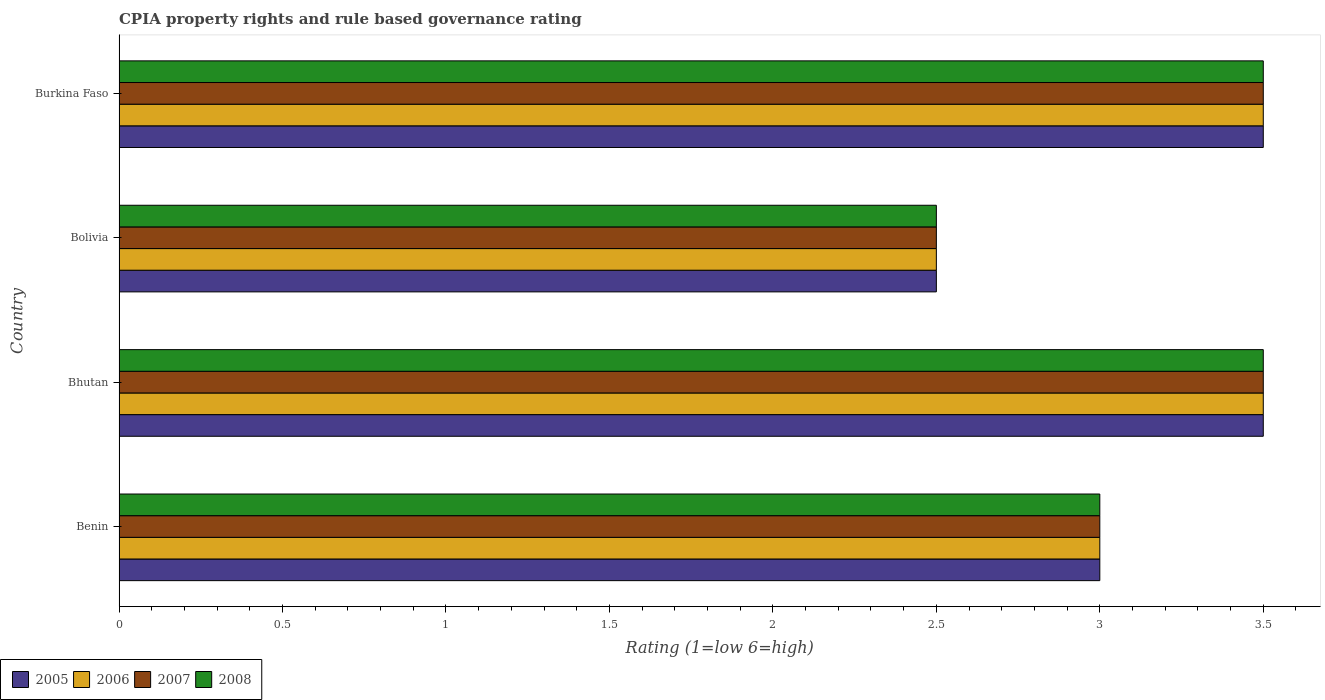Are the number of bars per tick equal to the number of legend labels?
Make the answer very short. Yes. What is the label of the 4th group of bars from the top?
Provide a short and direct response. Benin. In how many cases, is the number of bars for a given country not equal to the number of legend labels?
Provide a succinct answer. 0. What is the CPIA rating in 2005 in Bolivia?
Your response must be concise. 2.5. Across all countries, what is the minimum CPIA rating in 2006?
Your answer should be very brief. 2.5. In which country was the CPIA rating in 2007 maximum?
Your response must be concise. Bhutan. What is the total CPIA rating in 2008 in the graph?
Make the answer very short. 12.5. What is the difference between the CPIA rating in 2007 in Benin and that in Bolivia?
Ensure brevity in your answer.  0.5. What is the average CPIA rating in 2005 per country?
Offer a terse response. 3.12. What is the difference between the CPIA rating in 2008 and CPIA rating in 2005 in Bolivia?
Provide a succinct answer. 0. What is the ratio of the CPIA rating in 2005 in Bhutan to that in Burkina Faso?
Your answer should be compact. 1. What is the difference between the highest and the second highest CPIA rating in 2005?
Provide a succinct answer. 0. In how many countries, is the CPIA rating in 2007 greater than the average CPIA rating in 2007 taken over all countries?
Your answer should be compact. 2. Is the sum of the CPIA rating in 2007 in Bhutan and Burkina Faso greater than the maximum CPIA rating in 2008 across all countries?
Offer a terse response. Yes. Is it the case that in every country, the sum of the CPIA rating in 2005 and CPIA rating in 2007 is greater than the sum of CPIA rating in 2008 and CPIA rating in 2006?
Ensure brevity in your answer.  No. What does the 1st bar from the top in Burkina Faso represents?
Provide a short and direct response. 2008. What does the 1st bar from the bottom in Bolivia represents?
Offer a very short reply. 2005. How many bars are there?
Your response must be concise. 16. Are all the bars in the graph horizontal?
Your response must be concise. Yes. How many countries are there in the graph?
Provide a short and direct response. 4. Are the values on the major ticks of X-axis written in scientific E-notation?
Give a very brief answer. No. Does the graph contain any zero values?
Provide a succinct answer. No. Does the graph contain grids?
Give a very brief answer. No. Where does the legend appear in the graph?
Ensure brevity in your answer.  Bottom left. How many legend labels are there?
Offer a terse response. 4. How are the legend labels stacked?
Your answer should be very brief. Horizontal. What is the title of the graph?
Provide a short and direct response. CPIA property rights and rule based governance rating. Does "1977" appear as one of the legend labels in the graph?
Offer a very short reply. No. What is the Rating (1=low 6=high) in 2007 in Bhutan?
Your answer should be compact. 3.5. What is the Rating (1=low 6=high) of 2005 in Bolivia?
Make the answer very short. 2.5. What is the Rating (1=low 6=high) of 2008 in Bolivia?
Give a very brief answer. 2.5. What is the Rating (1=low 6=high) in 2006 in Burkina Faso?
Make the answer very short. 3.5. What is the Rating (1=low 6=high) in 2008 in Burkina Faso?
Make the answer very short. 3.5. Across all countries, what is the maximum Rating (1=low 6=high) of 2007?
Your answer should be very brief. 3.5. Across all countries, what is the minimum Rating (1=low 6=high) of 2005?
Provide a short and direct response. 2.5. What is the total Rating (1=low 6=high) of 2006 in the graph?
Offer a terse response. 12.5. What is the total Rating (1=low 6=high) of 2007 in the graph?
Your response must be concise. 12.5. What is the total Rating (1=low 6=high) in 2008 in the graph?
Your answer should be compact. 12.5. What is the difference between the Rating (1=low 6=high) of 2006 in Benin and that in Bhutan?
Your answer should be very brief. -0.5. What is the difference between the Rating (1=low 6=high) of 2007 in Benin and that in Bhutan?
Ensure brevity in your answer.  -0.5. What is the difference between the Rating (1=low 6=high) of 2006 in Benin and that in Bolivia?
Offer a terse response. 0.5. What is the difference between the Rating (1=low 6=high) of 2007 in Benin and that in Bolivia?
Give a very brief answer. 0.5. What is the difference between the Rating (1=low 6=high) in 2005 in Benin and that in Burkina Faso?
Give a very brief answer. -0.5. What is the difference between the Rating (1=low 6=high) in 2007 in Benin and that in Burkina Faso?
Ensure brevity in your answer.  -0.5. What is the difference between the Rating (1=low 6=high) in 2008 in Benin and that in Burkina Faso?
Your response must be concise. -0.5. What is the difference between the Rating (1=low 6=high) of 2006 in Bhutan and that in Bolivia?
Provide a short and direct response. 1. What is the difference between the Rating (1=low 6=high) of 2007 in Bhutan and that in Burkina Faso?
Offer a terse response. 0. What is the difference between the Rating (1=low 6=high) in 2005 in Bolivia and that in Burkina Faso?
Keep it short and to the point. -1. What is the difference between the Rating (1=low 6=high) of 2006 in Bolivia and that in Burkina Faso?
Offer a very short reply. -1. What is the difference between the Rating (1=low 6=high) in 2007 in Bolivia and that in Burkina Faso?
Your answer should be compact. -1. What is the difference between the Rating (1=low 6=high) in 2005 in Benin and the Rating (1=low 6=high) in 2008 in Bhutan?
Offer a terse response. -0.5. What is the difference between the Rating (1=low 6=high) in 2006 in Benin and the Rating (1=low 6=high) in 2008 in Bhutan?
Offer a very short reply. -0.5. What is the difference between the Rating (1=low 6=high) of 2005 in Benin and the Rating (1=low 6=high) of 2008 in Bolivia?
Your answer should be very brief. 0.5. What is the difference between the Rating (1=low 6=high) of 2006 in Benin and the Rating (1=low 6=high) of 2007 in Bolivia?
Your response must be concise. 0.5. What is the difference between the Rating (1=low 6=high) of 2007 in Benin and the Rating (1=low 6=high) of 2008 in Bolivia?
Provide a short and direct response. 0.5. What is the difference between the Rating (1=low 6=high) of 2005 in Benin and the Rating (1=low 6=high) of 2007 in Burkina Faso?
Keep it short and to the point. -0.5. What is the difference between the Rating (1=low 6=high) of 2005 in Benin and the Rating (1=low 6=high) of 2008 in Burkina Faso?
Your response must be concise. -0.5. What is the difference between the Rating (1=low 6=high) of 2006 in Benin and the Rating (1=low 6=high) of 2008 in Burkina Faso?
Provide a succinct answer. -0.5. What is the difference between the Rating (1=low 6=high) in 2007 in Benin and the Rating (1=low 6=high) in 2008 in Burkina Faso?
Offer a very short reply. -0.5. What is the difference between the Rating (1=low 6=high) of 2005 in Bhutan and the Rating (1=low 6=high) of 2006 in Bolivia?
Offer a terse response. 1. What is the difference between the Rating (1=low 6=high) in 2005 in Bhutan and the Rating (1=low 6=high) in 2007 in Bolivia?
Provide a succinct answer. 1. What is the difference between the Rating (1=low 6=high) of 2005 in Bhutan and the Rating (1=low 6=high) of 2008 in Bolivia?
Offer a terse response. 1. What is the difference between the Rating (1=low 6=high) of 2006 in Bhutan and the Rating (1=low 6=high) of 2007 in Bolivia?
Provide a short and direct response. 1. What is the difference between the Rating (1=low 6=high) of 2005 in Bhutan and the Rating (1=low 6=high) of 2008 in Burkina Faso?
Keep it short and to the point. 0. What is the difference between the Rating (1=low 6=high) in 2006 in Bolivia and the Rating (1=low 6=high) in 2008 in Burkina Faso?
Your answer should be compact. -1. What is the average Rating (1=low 6=high) of 2005 per country?
Give a very brief answer. 3.12. What is the average Rating (1=low 6=high) in 2006 per country?
Your answer should be compact. 3.12. What is the average Rating (1=low 6=high) in 2007 per country?
Ensure brevity in your answer.  3.12. What is the average Rating (1=low 6=high) in 2008 per country?
Keep it short and to the point. 3.12. What is the difference between the Rating (1=low 6=high) of 2005 and Rating (1=low 6=high) of 2006 in Benin?
Ensure brevity in your answer.  0. What is the difference between the Rating (1=low 6=high) in 2006 and Rating (1=low 6=high) in 2007 in Benin?
Offer a terse response. 0. What is the difference between the Rating (1=low 6=high) of 2006 and Rating (1=low 6=high) of 2008 in Benin?
Your answer should be compact. 0. What is the difference between the Rating (1=low 6=high) in 2005 and Rating (1=low 6=high) in 2007 in Bhutan?
Your answer should be very brief. 0. What is the difference between the Rating (1=low 6=high) of 2006 and Rating (1=low 6=high) of 2008 in Bhutan?
Offer a terse response. 0. What is the difference between the Rating (1=low 6=high) in 2007 and Rating (1=low 6=high) in 2008 in Bhutan?
Keep it short and to the point. 0. What is the difference between the Rating (1=low 6=high) in 2005 and Rating (1=low 6=high) in 2006 in Bolivia?
Offer a very short reply. 0. What is the difference between the Rating (1=low 6=high) in 2007 and Rating (1=low 6=high) in 2008 in Bolivia?
Give a very brief answer. 0. What is the difference between the Rating (1=low 6=high) in 2005 and Rating (1=low 6=high) in 2008 in Burkina Faso?
Make the answer very short. 0. What is the difference between the Rating (1=low 6=high) in 2006 and Rating (1=low 6=high) in 2008 in Burkina Faso?
Ensure brevity in your answer.  0. What is the ratio of the Rating (1=low 6=high) of 2007 in Benin to that in Bhutan?
Your answer should be compact. 0.86. What is the ratio of the Rating (1=low 6=high) of 2008 in Benin to that in Bhutan?
Provide a short and direct response. 0.86. What is the ratio of the Rating (1=low 6=high) in 2005 in Benin to that in Bolivia?
Keep it short and to the point. 1.2. What is the ratio of the Rating (1=low 6=high) in 2006 in Benin to that in Burkina Faso?
Give a very brief answer. 0.86. What is the ratio of the Rating (1=low 6=high) in 2007 in Benin to that in Burkina Faso?
Your answer should be very brief. 0.86. What is the ratio of the Rating (1=low 6=high) of 2007 in Bhutan to that in Burkina Faso?
Ensure brevity in your answer.  1. What is the ratio of the Rating (1=low 6=high) in 2008 in Bhutan to that in Burkina Faso?
Make the answer very short. 1. What is the ratio of the Rating (1=low 6=high) in 2007 in Bolivia to that in Burkina Faso?
Provide a short and direct response. 0.71. What is the difference between the highest and the second highest Rating (1=low 6=high) in 2005?
Give a very brief answer. 0. What is the difference between the highest and the second highest Rating (1=low 6=high) in 2006?
Offer a terse response. 0. What is the difference between the highest and the second highest Rating (1=low 6=high) in 2007?
Provide a short and direct response. 0. What is the difference between the highest and the lowest Rating (1=low 6=high) in 2005?
Your answer should be compact. 1. What is the difference between the highest and the lowest Rating (1=low 6=high) of 2006?
Provide a succinct answer. 1. 